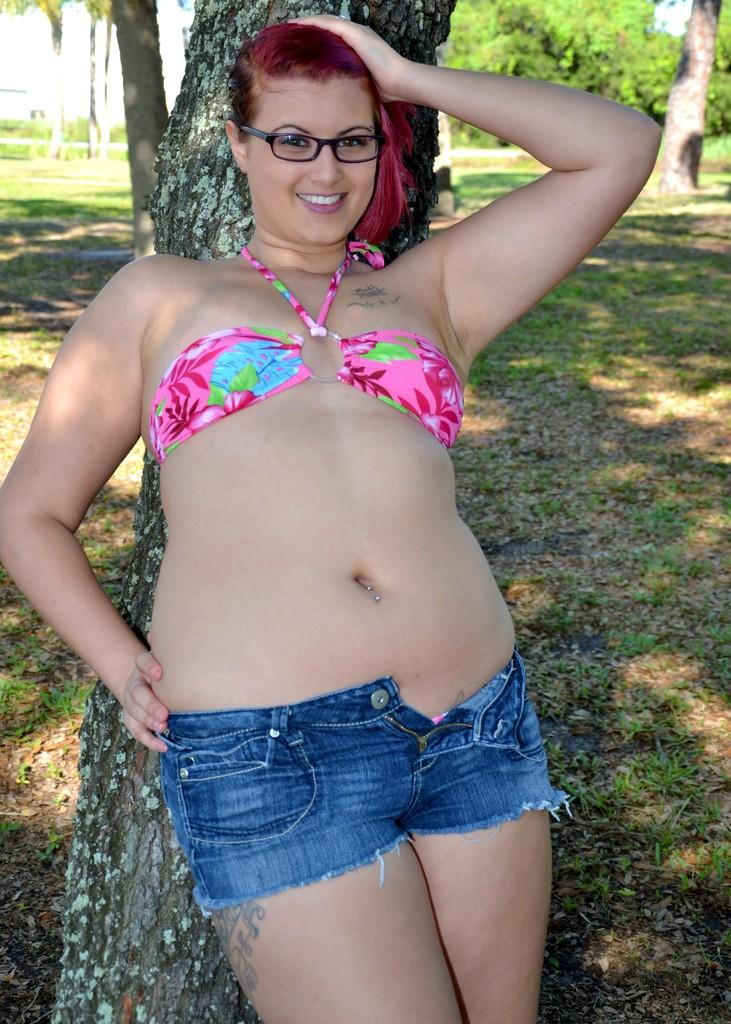What is the person in the image doing? The person is standing at a tree in the image. What can be seen in the background of the image? There are many trees and grass visible in the background of the image. What type of invention can be seen in the hands of the person standing at the tree? There is no invention visible in the hands of the person standing at the tree in the image. Can you tell me how many tigers are hiding behind the trees in the background? There are no tigers present in the image; it features a person standing at a tree and many trees in the background. 